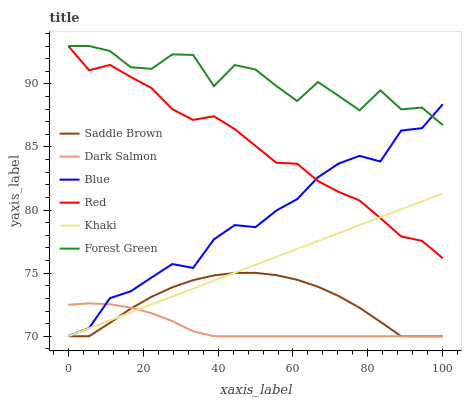Does Dark Salmon have the minimum area under the curve?
Answer yes or no. Yes. Does Forest Green have the maximum area under the curve?
Answer yes or no. Yes. Does Khaki have the minimum area under the curve?
Answer yes or no. No. Does Khaki have the maximum area under the curve?
Answer yes or no. No. Is Khaki the smoothest?
Answer yes or no. Yes. Is Forest Green the roughest?
Answer yes or no. Yes. Is Dark Salmon the smoothest?
Answer yes or no. No. Is Dark Salmon the roughest?
Answer yes or no. No. Does Forest Green have the lowest value?
Answer yes or no. No. Does Red have the highest value?
Answer yes or no. Yes. Does Khaki have the highest value?
Answer yes or no. No. Is Khaki less than Forest Green?
Answer yes or no. Yes. Is Red greater than Dark Salmon?
Answer yes or no. Yes. Does Khaki intersect Forest Green?
Answer yes or no. No. 